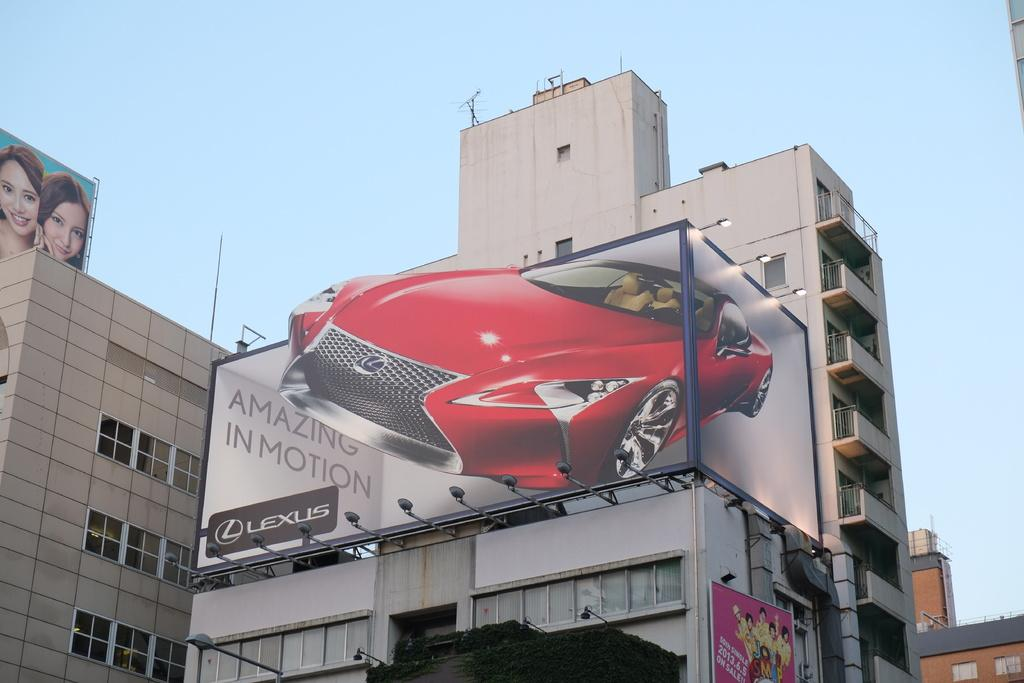What type of structures can be seen in the image? There are buildings in the image. What is located in the middle of the image? There is a banner in the middle of the image. What is depicted on the banner? The banner contains an image of a car. Are there any words on the banner? Yes, the banner contains some text. What is visible at the top of the image? The sky is visible at the top of the image. What type of flowers are growing on the level of the banner in the image? There are no flowers present in the image, and the banner is not a level surface. 